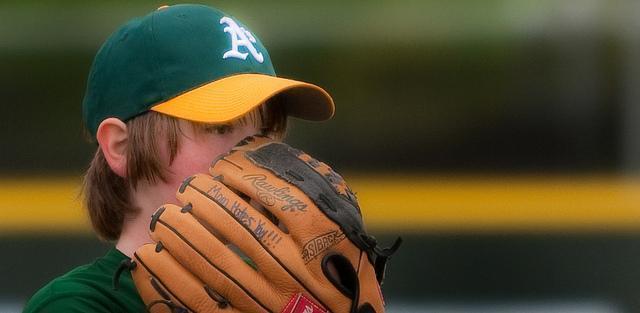How many rolls of toilet paper in this scene?
Give a very brief answer. 0. 